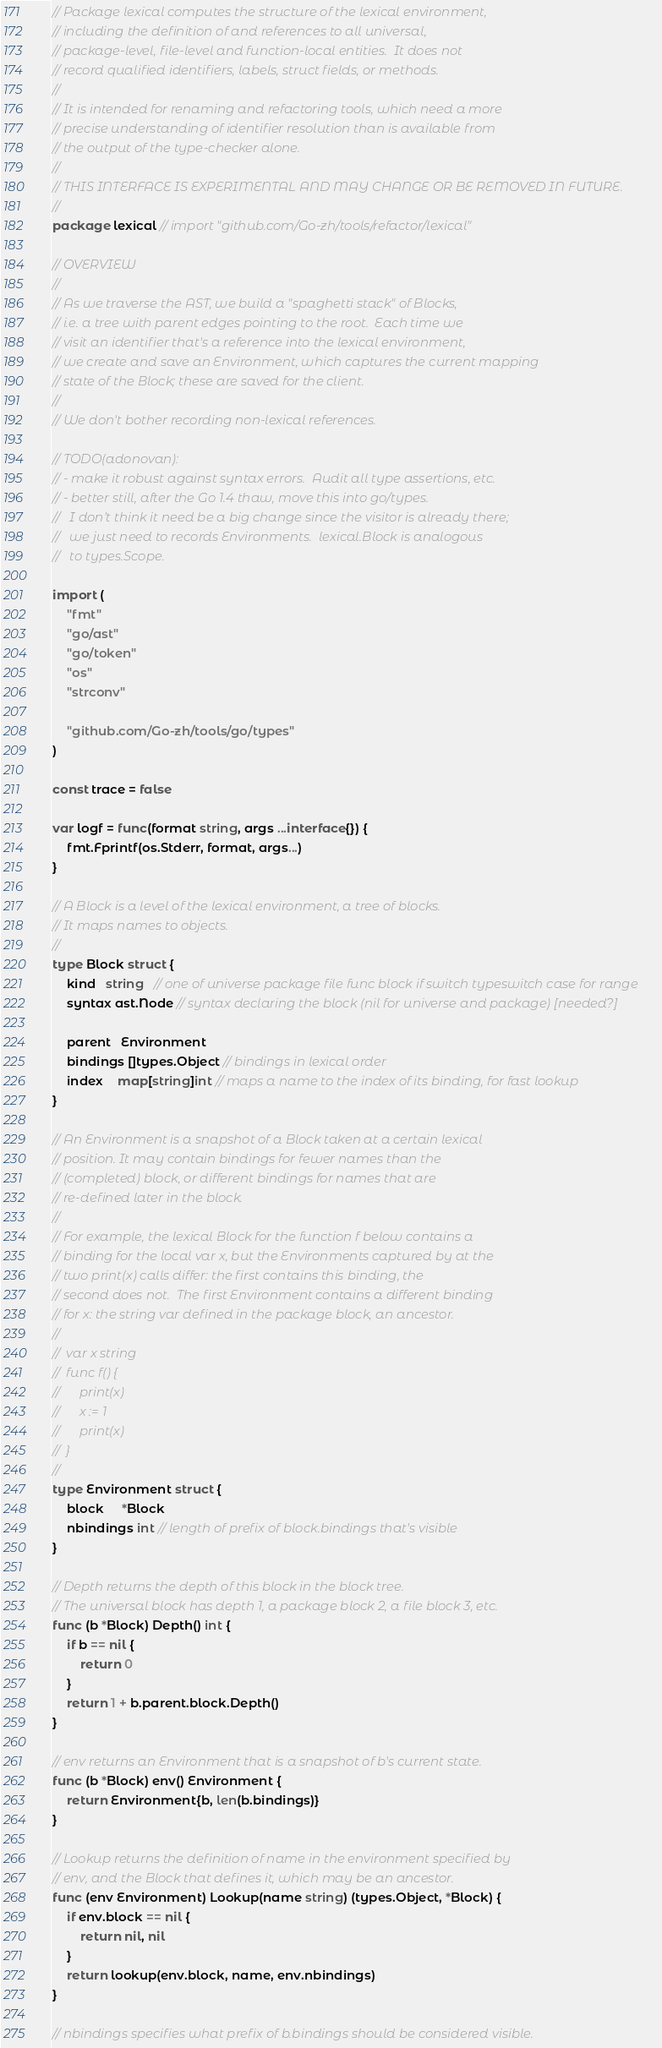<code> <loc_0><loc_0><loc_500><loc_500><_Go_>// Package lexical computes the structure of the lexical environment,
// including the definition of and references to all universal,
// package-level, file-level and function-local entities.  It does not
// record qualified identifiers, labels, struct fields, or methods.
//
// It is intended for renaming and refactoring tools, which need a more
// precise understanding of identifier resolution than is available from
// the output of the type-checker alone.
//
// THIS INTERFACE IS EXPERIMENTAL AND MAY CHANGE OR BE REMOVED IN FUTURE.
//
package lexical // import "github.com/Go-zh/tools/refactor/lexical"

// OVERVIEW
//
// As we traverse the AST, we build a "spaghetti stack" of Blocks,
// i.e. a tree with parent edges pointing to the root.  Each time we
// visit an identifier that's a reference into the lexical environment,
// we create and save an Environment, which captures the current mapping
// state of the Block; these are saved for the client.
//
// We don't bother recording non-lexical references.

// TODO(adonovan):
// - make it robust against syntax errors.  Audit all type assertions, etc.
// - better still, after the Go 1.4 thaw, move this into go/types.
//   I don't think it need be a big change since the visitor is already there;
//   we just need to records Environments.  lexical.Block is analogous
//   to types.Scope.

import (
	"fmt"
	"go/ast"
	"go/token"
	"os"
	"strconv"

	"github.com/Go-zh/tools/go/types"
)

const trace = false

var logf = func(format string, args ...interface{}) {
	fmt.Fprintf(os.Stderr, format, args...)
}

// A Block is a level of the lexical environment, a tree of blocks.
// It maps names to objects.
//
type Block struct {
	kind   string   // one of universe package file func block if switch typeswitch case for range
	syntax ast.Node // syntax declaring the block (nil for universe and package) [needed?]

	parent   Environment
	bindings []types.Object // bindings in lexical order
	index    map[string]int // maps a name to the index of its binding, for fast lookup
}

// An Environment is a snapshot of a Block taken at a certain lexical
// position. It may contain bindings for fewer names than the
// (completed) block, or different bindings for names that are
// re-defined later in the block.
//
// For example, the lexical Block for the function f below contains a
// binding for the local var x, but the Environments captured by at the
// two print(x) calls differ: the first contains this binding, the
// second does not.  The first Environment contains a different binding
// for x: the string var defined in the package block, an ancestor.
//
//	var x string
// 	func f() {
//		print(x)
//		x := 1
//		print(x)
//	}
//
type Environment struct {
	block     *Block
	nbindings int // length of prefix of block.bindings that's visible
}

// Depth returns the depth of this block in the block tree.
// The universal block has depth 1, a package block 2, a file block 3, etc.
func (b *Block) Depth() int {
	if b == nil {
		return 0
	}
	return 1 + b.parent.block.Depth()
}

// env returns an Environment that is a snapshot of b's current state.
func (b *Block) env() Environment {
	return Environment{b, len(b.bindings)}
}

// Lookup returns the definition of name in the environment specified by
// env, and the Block that defines it, which may be an ancestor.
func (env Environment) Lookup(name string) (types.Object, *Block) {
	if env.block == nil {
		return nil, nil
	}
	return lookup(env.block, name, env.nbindings)
}

// nbindings specifies what prefix of b.bindings should be considered visible.</code> 